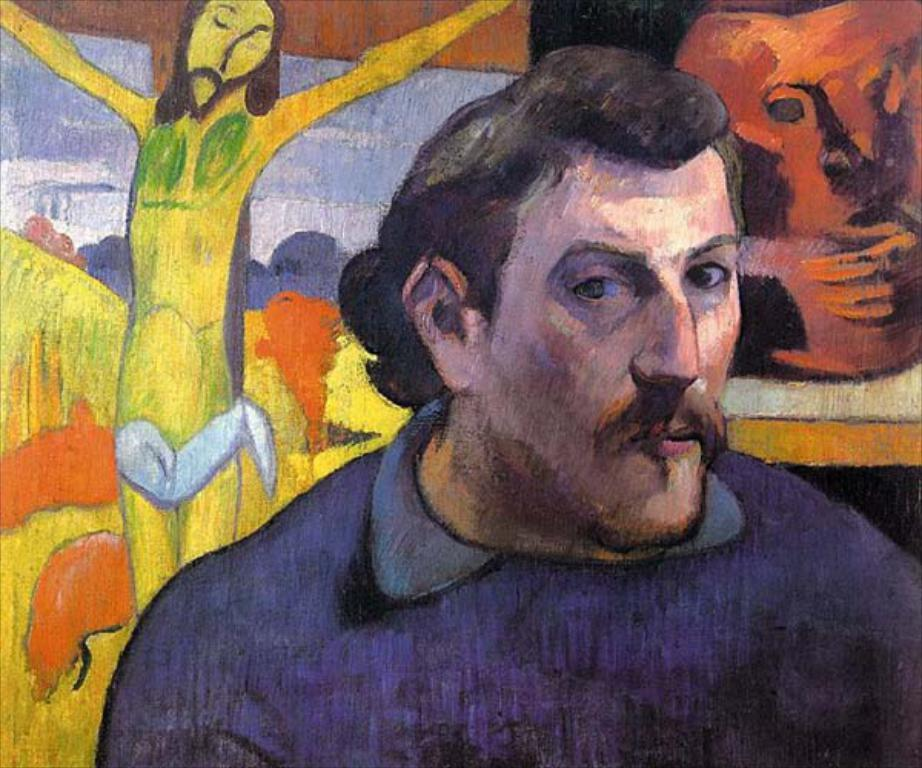What is the main subject of the image? There is a painting in the image. What does the painting depict? The painting depicts a man. Are there any other elements in the painting besides the man? Yes, there are objects present in the painting. How many books can be seen on the shelf in the painting? There is no shelf or books present in the painting; it depicts a man and objects. What type of machine is visible in the painting? There is no machine present in the painting; it depicts a man and objects. 